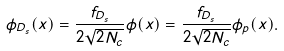<formula> <loc_0><loc_0><loc_500><loc_500>\phi _ { D _ { s } } ( x ) = \frac { f _ { D _ { s } } } { 2 \sqrt { 2 N _ { c } } } \phi ( x ) = \frac { f _ { D _ { s } } } { 2 \sqrt { 2 N _ { c } } } \phi _ { p } ( x ) .</formula> 